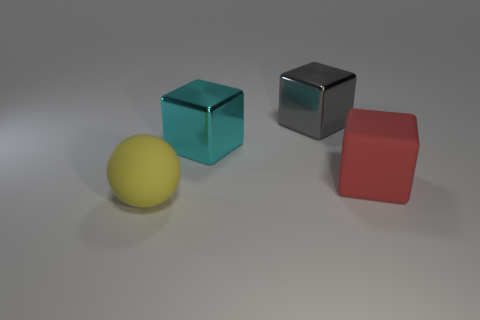Add 1 tiny red metal cylinders. How many objects exist? 5 Subtract all blocks. How many objects are left? 1 Subtract all small red shiny spheres. Subtract all big cyan things. How many objects are left? 3 Add 2 big yellow matte objects. How many big yellow matte objects are left? 3 Add 2 large red objects. How many large red objects exist? 3 Subtract 0 purple cubes. How many objects are left? 4 